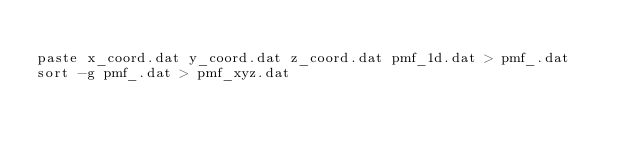Convert code to text. <code><loc_0><loc_0><loc_500><loc_500><_Bash_>
paste x_coord.dat y_coord.dat z_coord.dat pmf_1d.dat > pmf_.dat
sort -g pmf_.dat > pmf_xyz.dat
</code> 